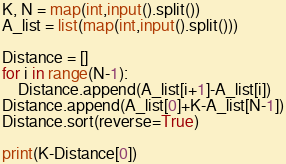<code> <loc_0><loc_0><loc_500><loc_500><_Python_>K, N = map(int,input().split())
A_list = list(map(int,input().split()))

Distance = []
for i in range(N-1):
    Distance.append(A_list[i+1]-A_list[i])
Distance.append(A_list[0]+K-A_list[N-1])
Distance.sort(reverse=True)

print(K-Distance[0])</code> 